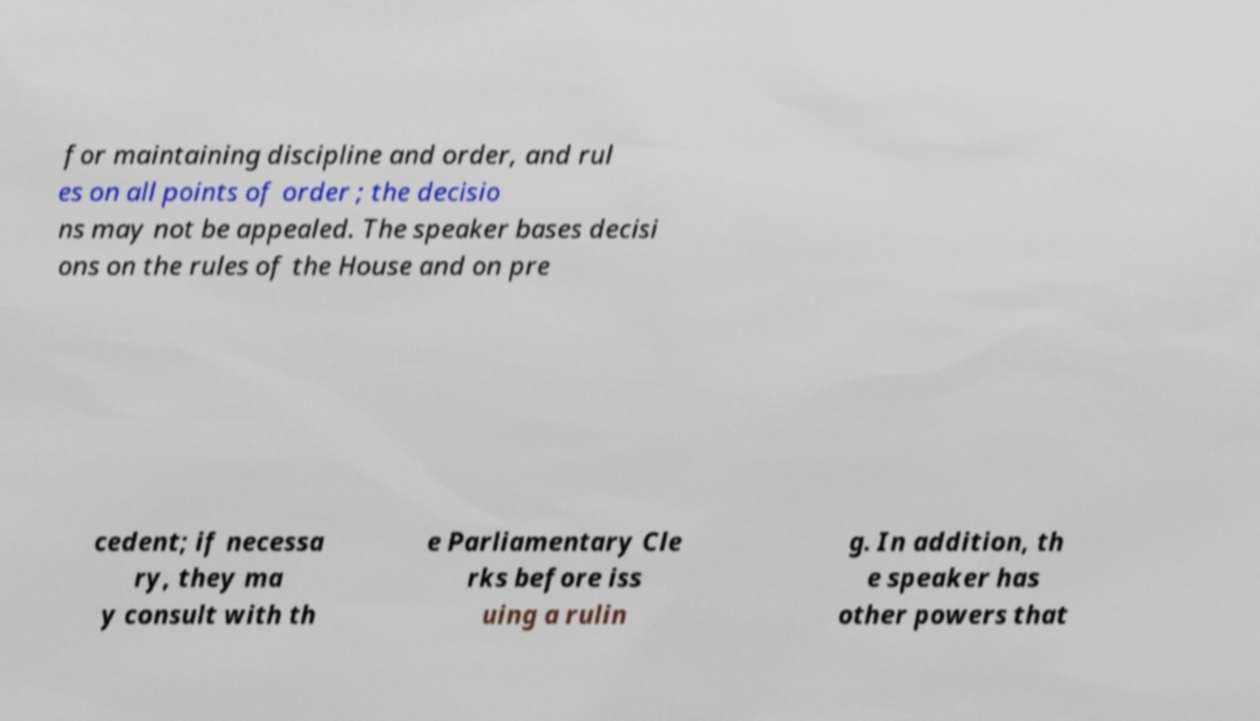Could you assist in decoding the text presented in this image and type it out clearly? for maintaining discipline and order, and rul es on all points of order ; the decisio ns may not be appealed. The speaker bases decisi ons on the rules of the House and on pre cedent; if necessa ry, they ma y consult with th e Parliamentary Cle rks before iss uing a rulin g. In addition, th e speaker has other powers that 